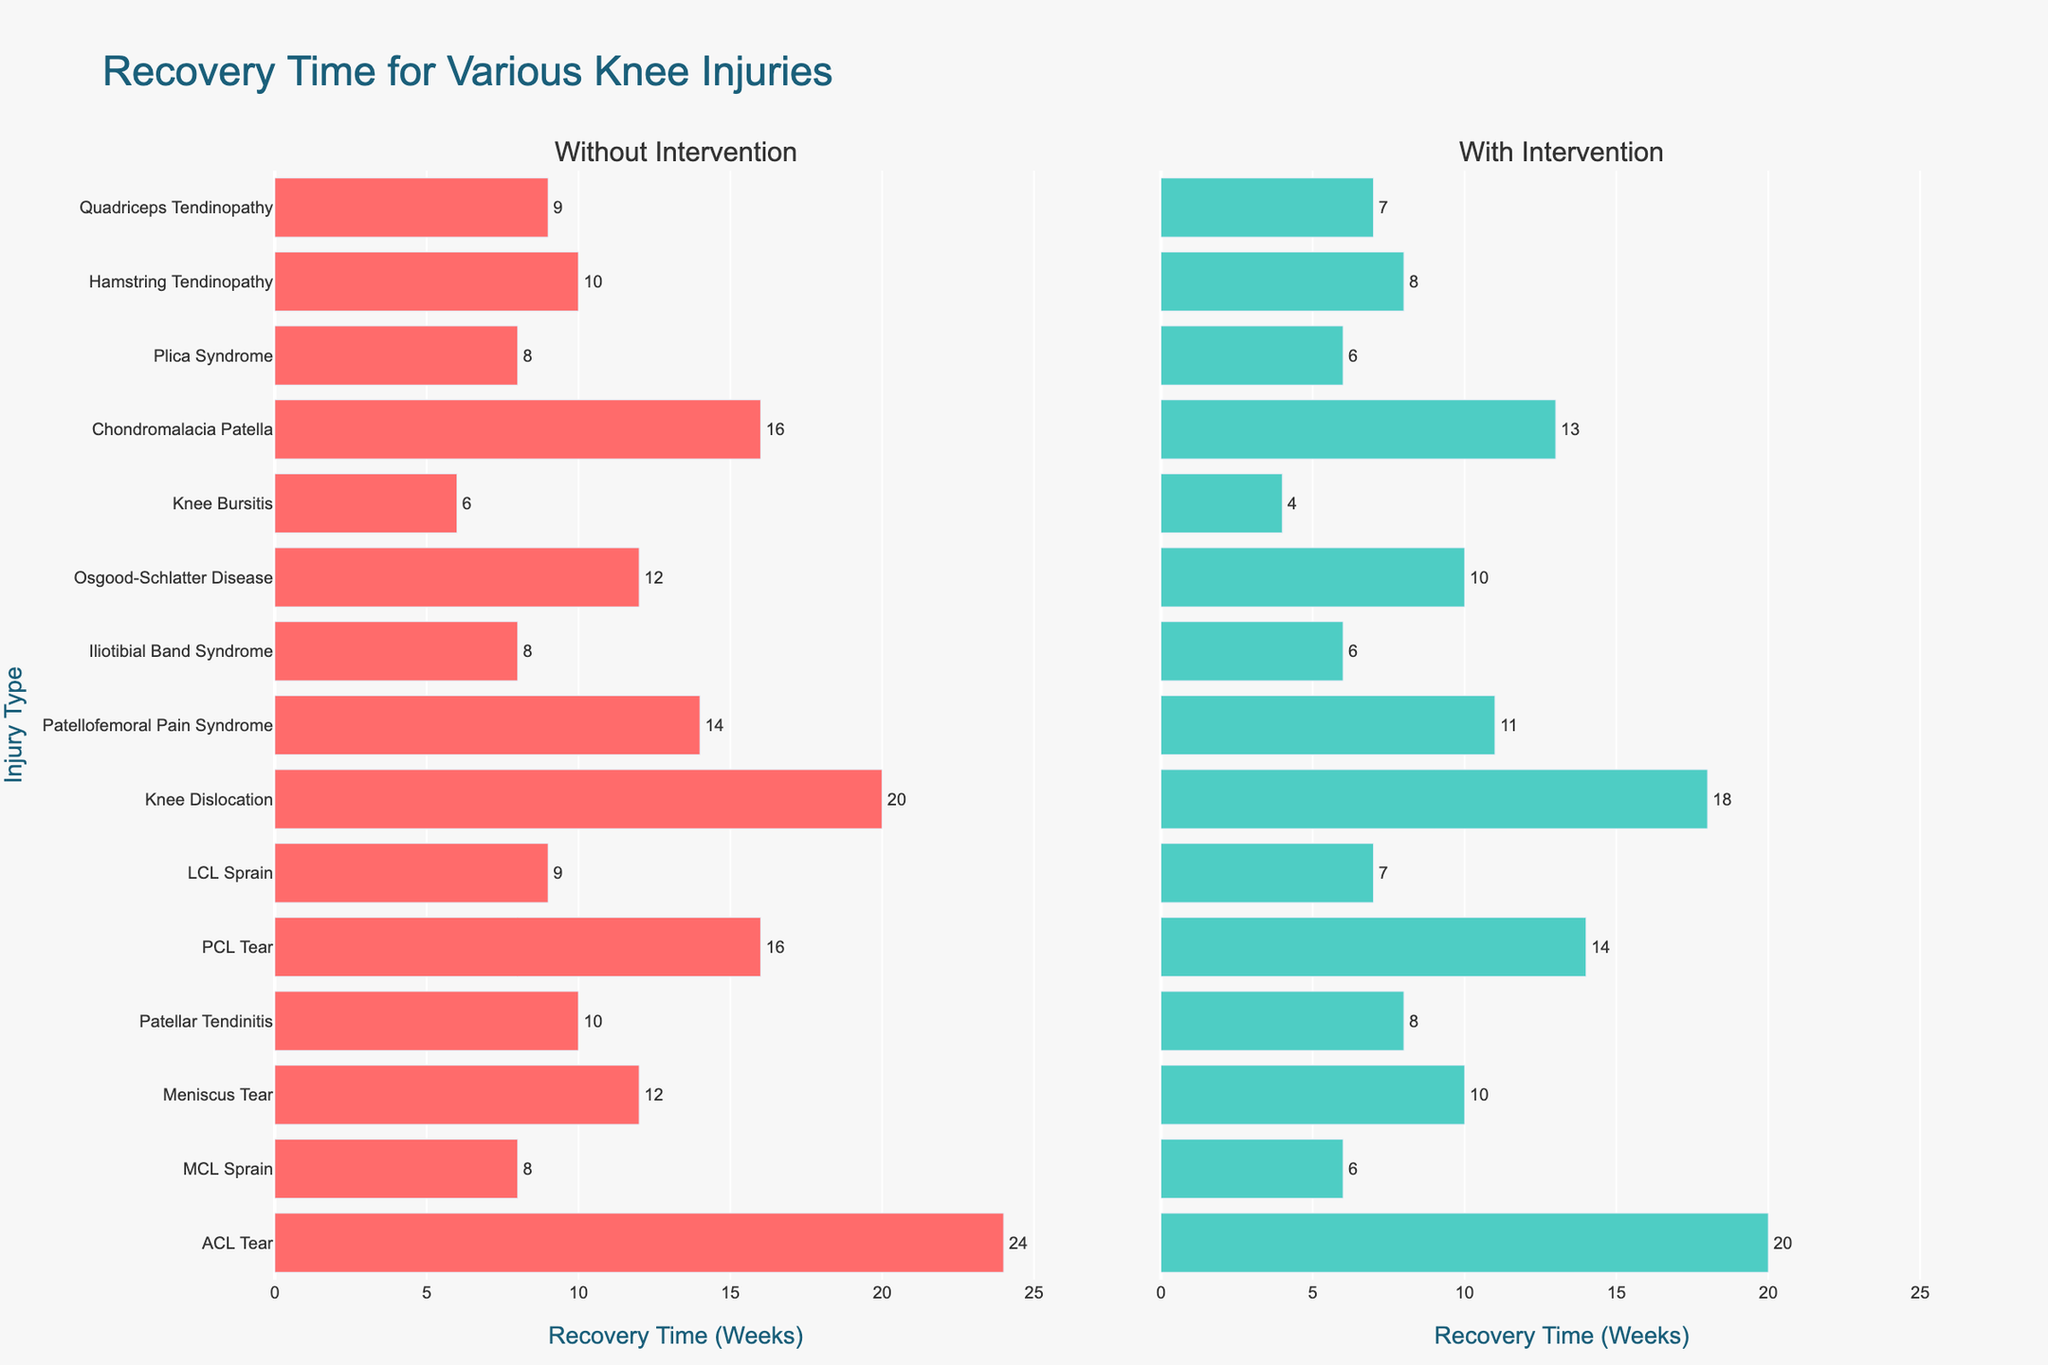Which injury type shows the largest reduction in recovery time with intervention? The bar representing "Patellofemoral Pain Syndrome" shows the most significant reduction from 14 weeks to 11 weeks, a difference of 3 weeks. This can be visually confirmed by comparing the lengths of the bars.
Answer: Patellofemoral Pain Syndrome Which injury type has the shortest recovery time without intervention? The bar representing "Knee Bursitis" is the shortest among those without intervention, indicating a recovery time of 6 weeks. Visually, it is the smallest bar in the left subplot.
Answer: Knee Bursitis What is the average recovery time for "ACL Tear" with and without intervention? The recovery time without intervention is 24 weeks and with intervention is 20 weeks. The average is calculated as (24 + 20) / 2 = 22 weeks.
Answer: 22 weeks Which two injury types have the same difference in recovery time (2 weeks) between with and without intervention? The bars representing "PCL Tear" (16 to 14 weeks) and "Knee Dislocation" (20 to 18 weeks) each show a 2-week difference in recovery time between the two conditions. This is verified by visually comparing the bar lengths for these injuries in both subplots.
Answer: PCL Tear and Knee Dislocation Which intervention color represents "With Intervention," and what is the corresponding color for "Without Intervention"? The bars in the right subplot ("With Intervention") are colored green, and those in the left subplot ("Without Intervention") are colored red.
Answer: Green for "With Intervention" and Red for "Without Intervention" How many injury types have a recovery time of 8 weeks without intervention and how many have the same duration with intervention? By looking at the left subplot, there are four injuries ("MCL Sprain," "Iliotibial Band Syndrome," "Plica Syndrome," and "Hamstring Tendinopathy") with 8 weeks recovery time without intervention. In the right subplot, "Patellar Tendinitis" and "Quadriceps Tendinopathy" each have 8 weeks with intervention.
Answer: 4 without intervention, 2 with intervention What is the total recovery time for all injuries without intervention, and how does this compare to the total recovery time with intervention? Sum the recovery times without intervention (24 + 8 + 12 + 10 + 16 + 9 + 20 + 14 + 8 + 12 + 6 + 16 + 8 + 10 + 9) = 182 weeks. For with intervention (20 + 6 + 10 + 8 + 14 + 7 + 18 + 11 + 6 + 10 + 4 + 13 + 6 + 8 + 7) = 148 weeks. The difference is 182 - 148 = 34 weeks.
Answer: 182 weeks without, 148 weeks with, 34 weeks difference Compare the recovery times for "Meniscus Tear" and "Osgood-Schlatter Disease" without and with intervention. Which has a larger absolute decrease? "Meniscus Tear" decreases from 12 weeks to 10 weeks (2 weeks difference), whereas "Osgood-Schlatter Disease" also decreases from 12 weeks to 10 weeks (2 weeks difference). Both have the same absolute decrease.
Answer: Equal decrease of 2 weeks each For how many injury types does the intervention reduce the recovery time by at least 4 weeks? The visual inspection reveals only one injury type, "Patellofemoral Pain Syndrome," where the recovery time reduces by 4 weeks (from 14 to 11 weeks) with intervention.
Answer: 1 injury type 